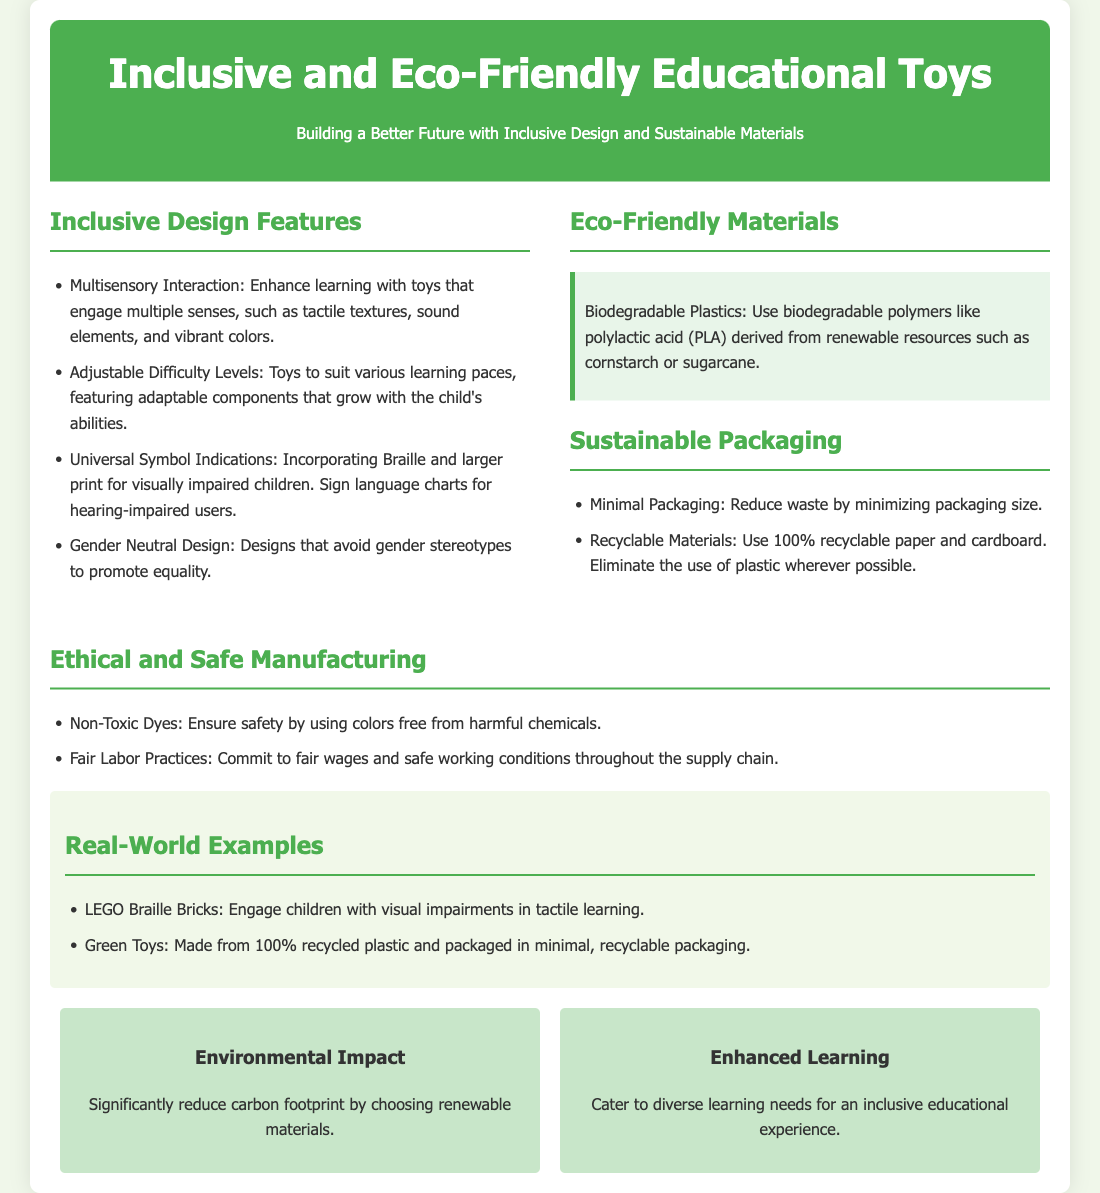What are the inclusive design features? The document lists specific features designed for inclusivity, including multisensory interaction, adjustable difficulty levels, universal symbol indications, and gender neutral design.
Answer: Multisensory interaction, adjustable difficulty levels, universal symbol indications, gender neutral design What is a type of biodegradable plastic used? The document mentions specific biodegradable materials, highlighting an example of a biodegradable polymer made from renewable resources.
Answer: Polylactic acid (PLA) What does the eco-friendly section specifically focus on? The eco-friendly section highlights the use of biodegradable plastics, detailing what they are derived from.
Answer: Biodegradable plastics What type of packaging materials are used? The document specifies the materials used in packaging, emphasizing sustainability and recyclability of certain components.
Answer: 100% recyclable paper and cardboard What are the benefits mentioned in the document? The benefits section outlines two key advantages of the products discussed, with a focus on environmental and educational impacts.
Answer: Environmental impact, enhanced learning How does the document address ethical manufacturing? The document points out practices aimed at ensuring safe and fair treatment of workers in the manufacturing process.
Answer: Fair labor practices Which example is given for visually impaired children? The document provides a real-world example related to a specific product designed for an audience with visual impairment.
Answer: LEGO Braille Bricks What is the main theme of this product packaging? The document's title and introductory paragraph provide insight into the overarching concept it promotes regarding the toys.
Answer: Inclusive Design and Sustainable Materials 